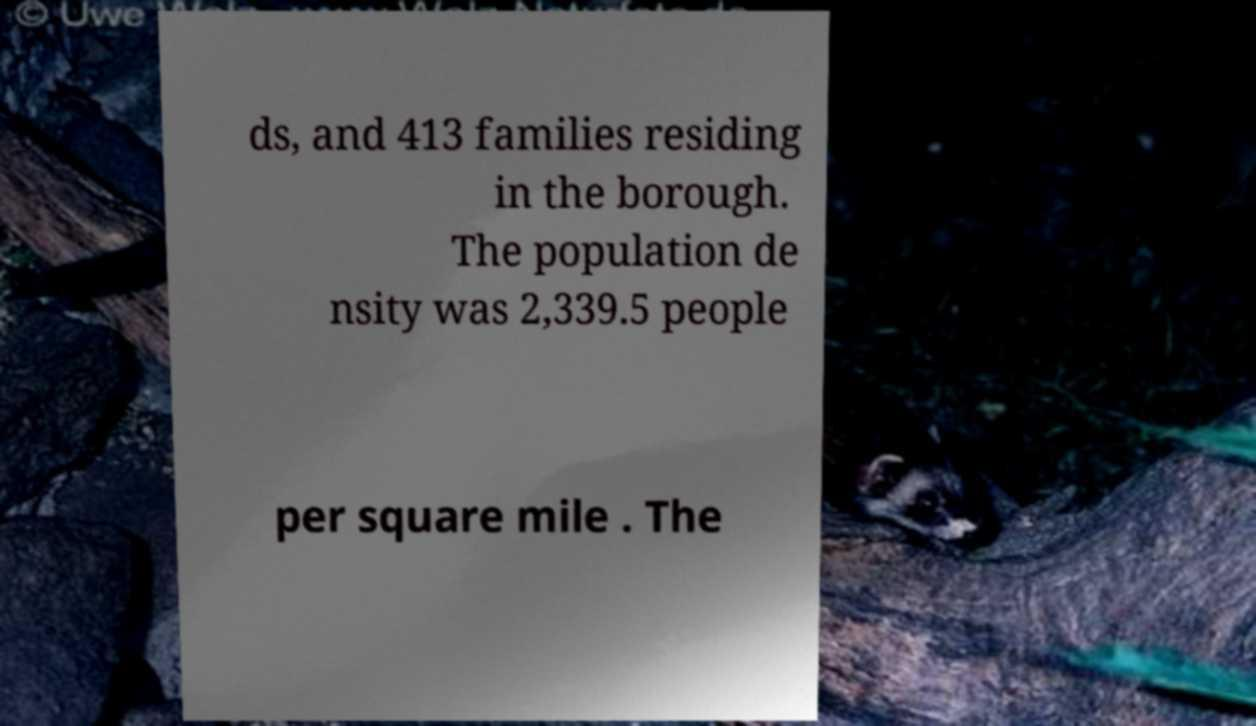Please read and relay the text visible in this image. What does it say? ds, and 413 families residing in the borough. The population de nsity was 2,339.5 people per square mile . The 